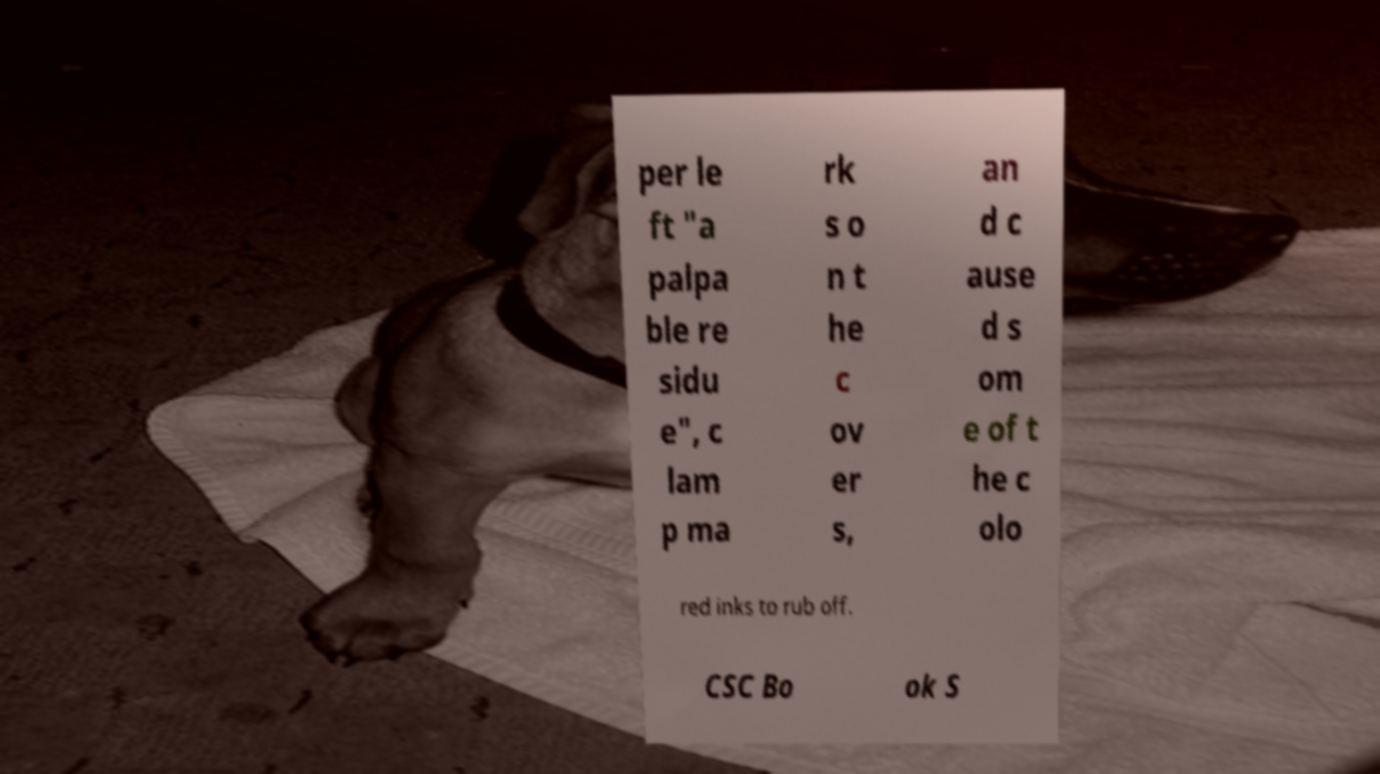What messages or text are displayed in this image? I need them in a readable, typed format. per le ft "a palpa ble re sidu e", c lam p ma rk s o n t he c ov er s, an d c ause d s om e of t he c olo red inks to rub off. CSC Bo ok S 